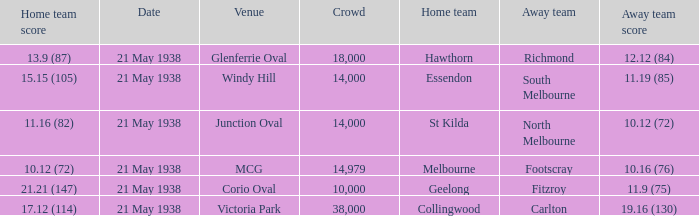Which Home team has a Venue of mcg? Melbourne. 